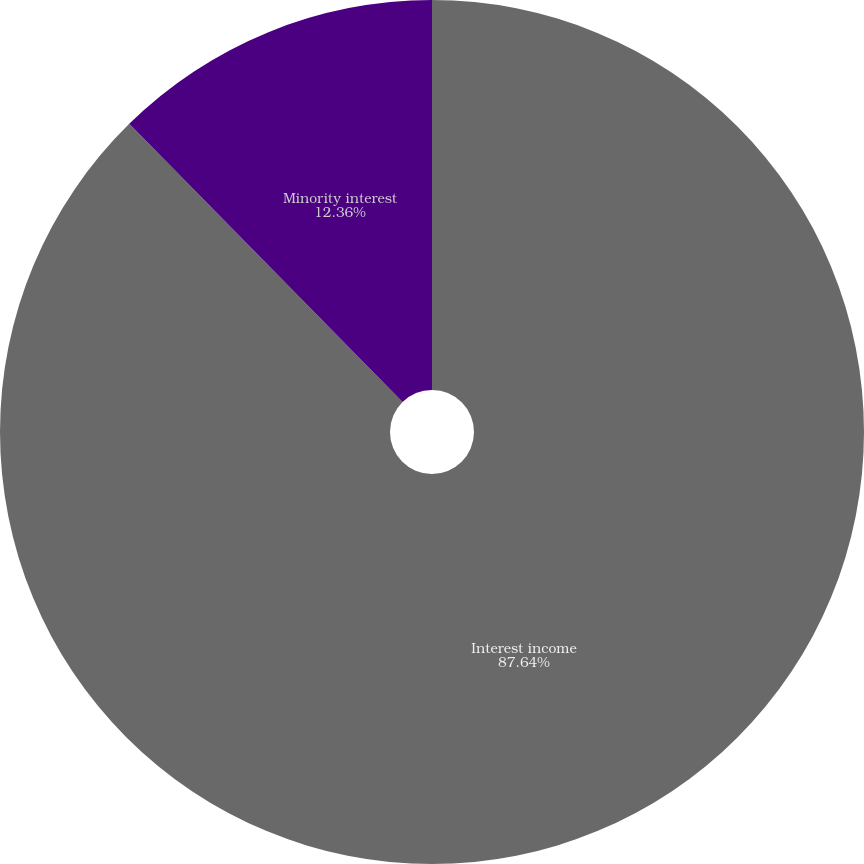Convert chart. <chart><loc_0><loc_0><loc_500><loc_500><pie_chart><fcel>Interest income<fcel>Minority interest<nl><fcel>87.64%<fcel>12.36%<nl></chart> 